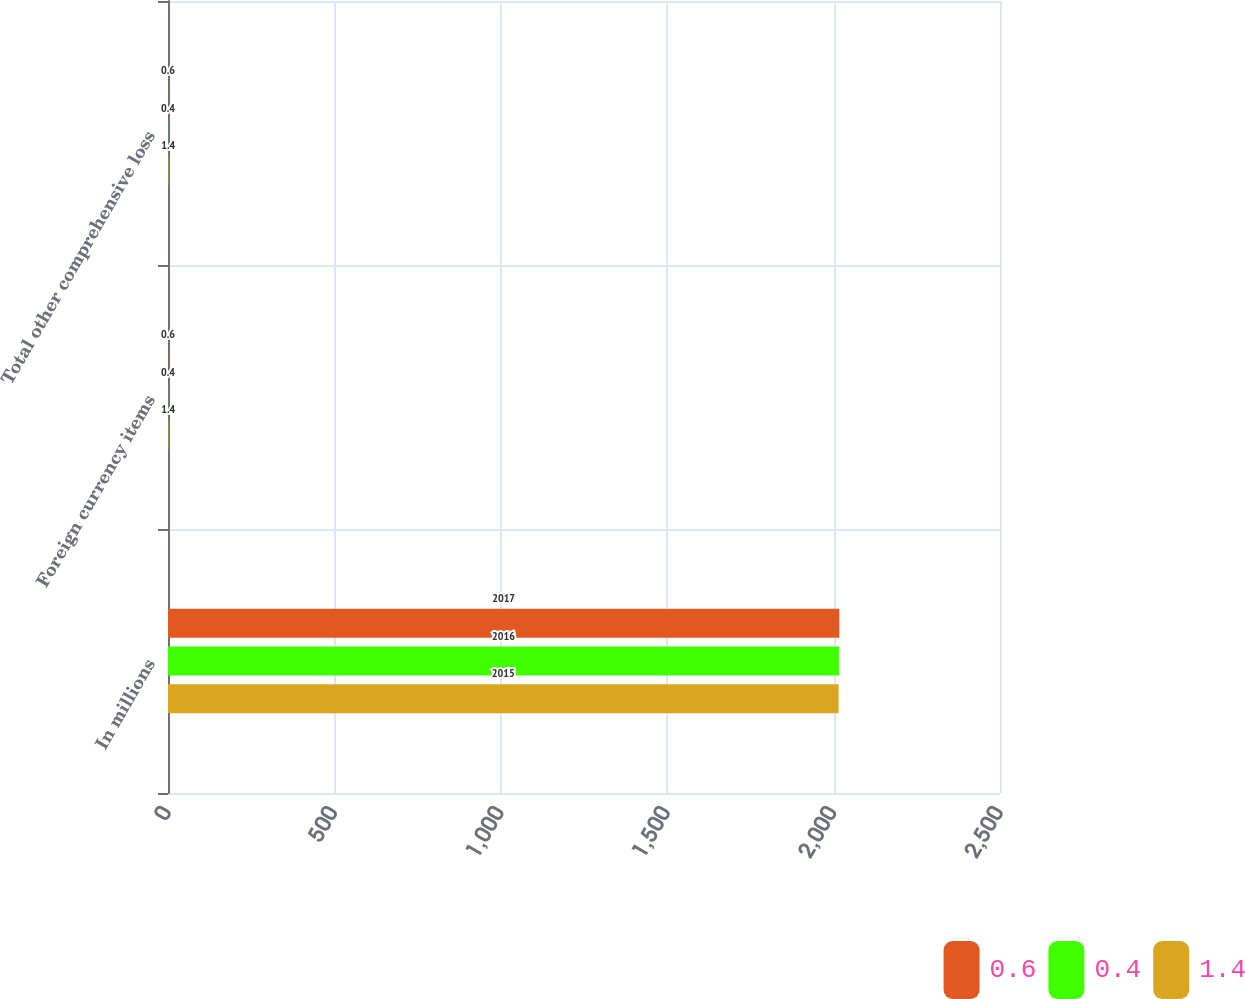Convert chart. <chart><loc_0><loc_0><loc_500><loc_500><stacked_bar_chart><ecel><fcel>In millions<fcel>Foreign currency items<fcel>Total other comprehensive loss<nl><fcel>0.6<fcel>2017<fcel>0.6<fcel>0.6<nl><fcel>0.4<fcel>2016<fcel>0.4<fcel>0.4<nl><fcel>1.4<fcel>2015<fcel>1.4<fcel>1.4<nl></chart> 